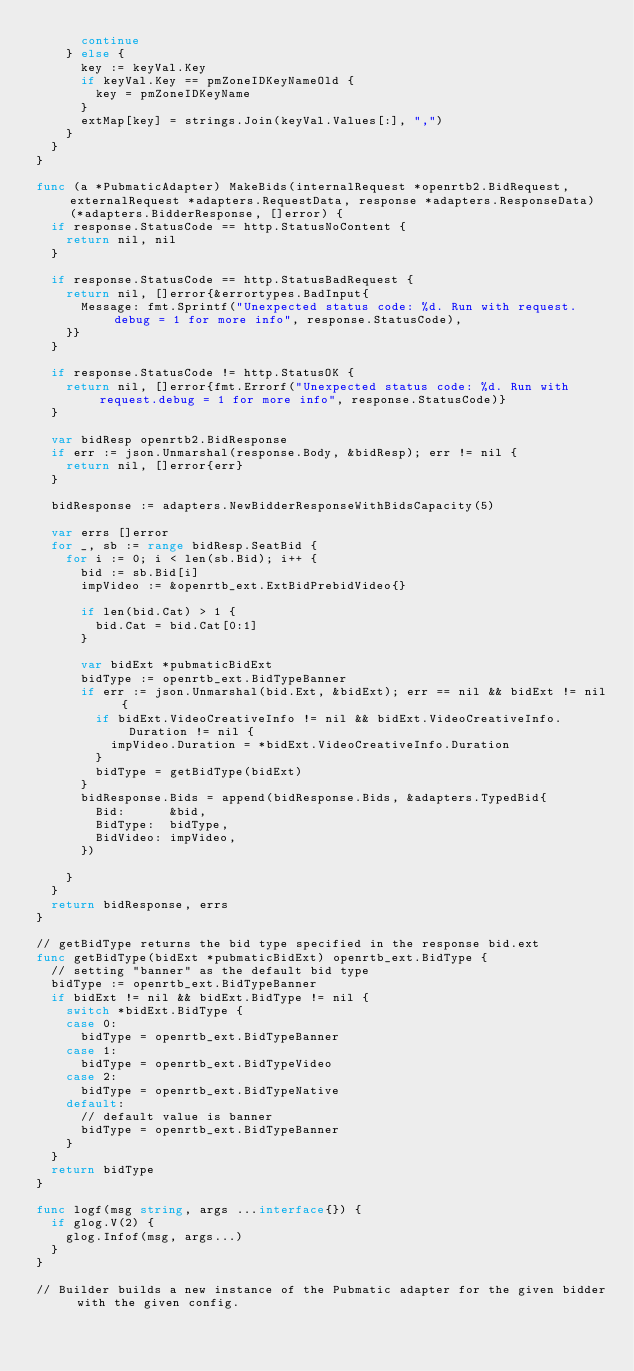Convert code to text. <code><loc_0><loc_0><loc_500><loc_500><_Go_>			continue
		} else {
			key := keyVal.Key
			if keyVal.Key == pmZoneIDKeyNameOld {
				key = pmZoneIDKeyName
			}
			extMap[key] = strings.Join(keyVal.Values[:], ",")
		}
	}
}

func (a *PubmaticAdapter) MakeBids(internalRequest *openrtb2.BidRequest, externalRequest *adapters.RequestData, response *adapters.ResponseData) (*adapters.BidderResponse, []error) {
	if response.StatusCode == http.StatusNoContent {
		return nil, nil
	}

	if response.StatusCode == http.StatusBadRequest {
		return nil, []error{&errortypes.BadInput{
			Message: fmt.Sprintf("Unexpected status code: %d. Run with request.debug = 1 for more info", response.StatusCode),
		}}
	}

	if response.StatusCode != http.StatusOK {
		return nil, []error{fmt.Errorf("Unexpected status code: %d. Run with request.debug = 1 for more info", response.StatusCode)}
	}

	var bidResp openrtb2.BidResponse
	if err := json.Unmarshal(response.Body, &bidResp); err != nil {
		return nil, []error{err}
	}

	bidResponse := adapters.NewBidderResponseWithBidsCapacity(5)

	var errs []error
	for _, sb := range bidResp.SeatBid {
		for i := 0; i < len(sb.Bid); i++ {
			bid := sb.Bid[i]
			impVideo := &openrtb_ext.ExtBidPrebidVideo{}

			if len(bid.Cat) > 1 {
				bid.Cat = bid.Cat[0:1]
			}

			var bidExt *pubmaticBidExt
			bidType := openrtb_ext.BidTypeBanner
			if err := json.Unmarshal(bid.Ext, &bidExt); err == nil && bidExt != nil {
				if bidExt.VideoCreativeInfo != nil && bidExt.VideoCreativeInfo.Duration != nil {
					impVideo.Duration = *bidExt.VideoCreativeInfo.Duration
				}
				bidType = getBidType(bidExt)
			}
			bidResponse.Bids = append(bidResponse.Bids, &adapters.TypedBid{
				Bid:      &bid,
				BidType:  bidType,
				BidVideo: impVideo,
			})

		}
	}
	return bidResponse, errs
}

// getBidType returns the bid type specified in the response bid.ext
func getBidType(bidExt *pubmaticBidExt) openrtb_ext.BidType {
	// setting "banner" as the default bid type
	bidType := openrtb_ext.BidTypeBanner
	if bidExt != nil && bidExt.BidType != nil {
		switch *bidExt.BidType {
		case 0:
			bidType = openrtb_ext.BidTypeBanner
		case 1:
			bidType = openrtb_ext.BidTypeVideo
		case 2:
			bidType = openrtb_ext.BidTypeNative
		default:
			// default value is banner
			bidType = openrtb_ext.BidTypeBanner
		}
	}
	return bidType
}

func logf(msg string, args ...interface{}) {
	if glog.V(2) {
		glog.Infof(msg, args...)
	}
}

// Builder builds a new instance of the Pubmatic adapter for the given bidder with the given config.</code> 